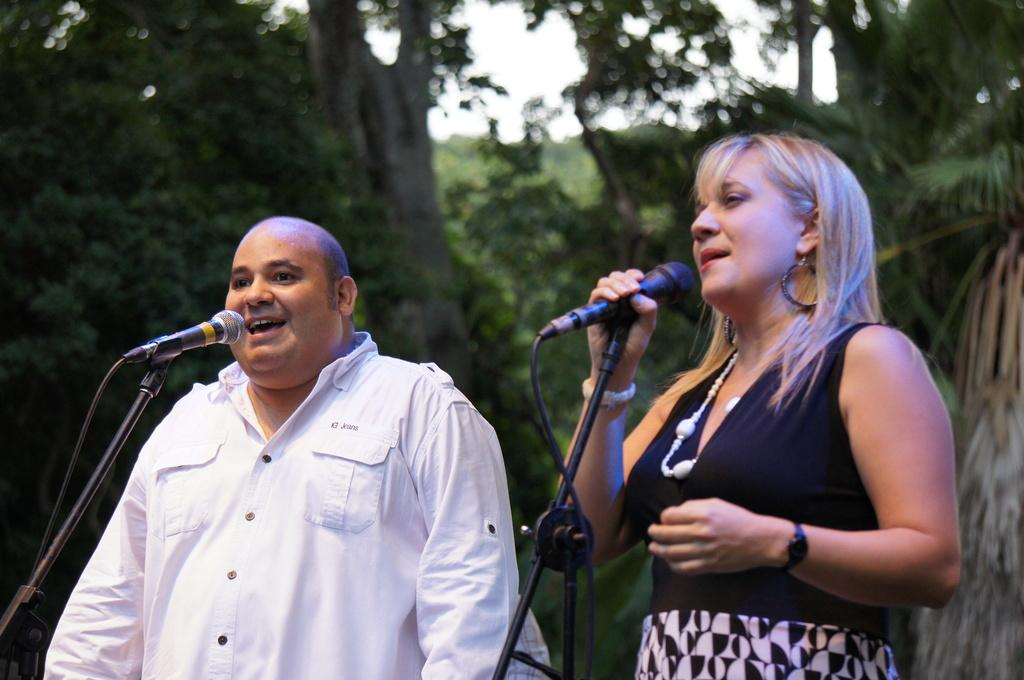What is the man in the image doing? The man is singing on a mic in the image. What is the man wearing? The man is wearing a white shirt in the image. What is the appearance of the man's head? The man is bald-headed in the image. What is the woman in the image doing? The woman is singing on a mic in the image. What is the color of the woman's hair? The woman has blond hair in the image. What can be seen in the background of the image? There are trees and the sky visible in the background of the image. What type of cake is being served at the governor's event in the image? There is no cake or governor's event present in the image; it features a man and a woman singing on mics. What type of frame is around the image? The provided facts do not mention a frame around the image. 